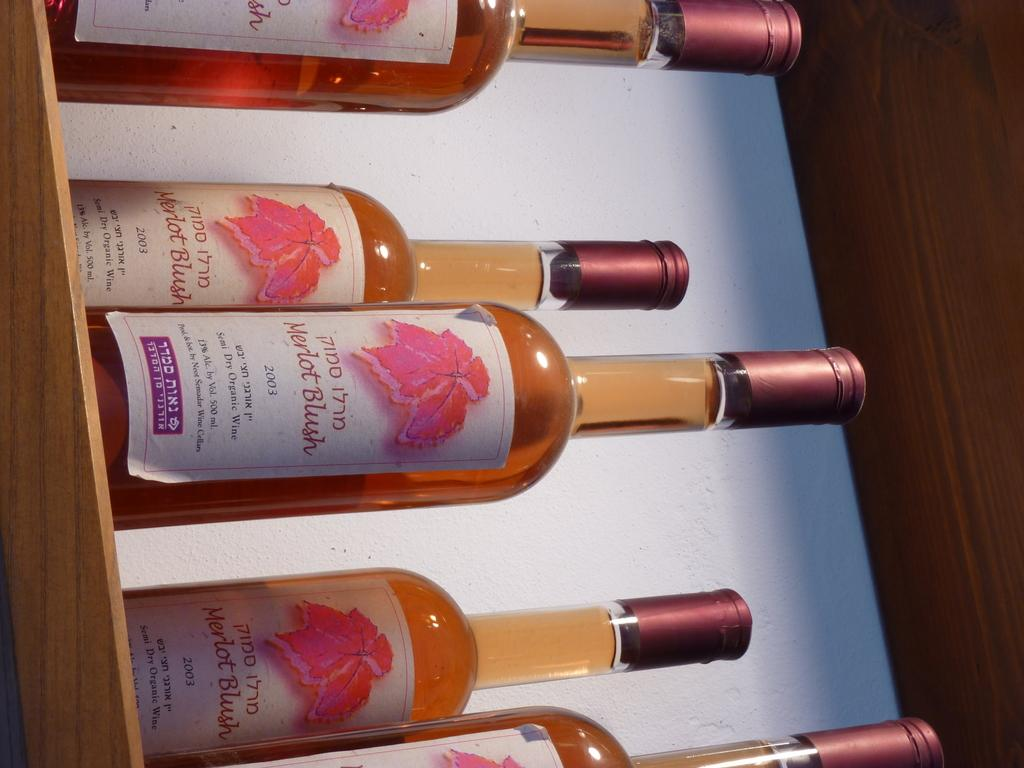What objects can be seen in the image? There are bottles in the image. Where are the bottles located? The bottles are on a table. What type of request can be seen being made by the fire in the image? There is no fire present in the image, so it is not possible to answer that question. 